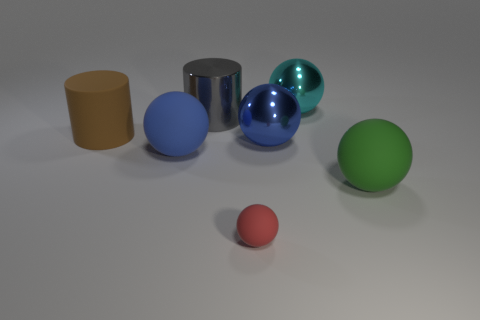How many blue spheres must be subtracted to get 1 blue spheres? 1 Subtract 1 spheres. How many spheres are left? 4 Subtract all red balls. How many balls are left? 4 Subtract all red matte balls. How many balls are left? 4 Subtract all yellow balls. Subtract all blue cubes. How many balls are left? 5 Add 3 matte things. How many objects exist? 10 Subtract all spheres. How many objects are left? 2 Subtract 0 blue blocks. How many objects are left? 7 Subtract all small red cylinders. Subtract all brown cylinders. How many objects are left? 6 Add 5 big brown rubber objects. How many big brown rubber objects are left? 6 